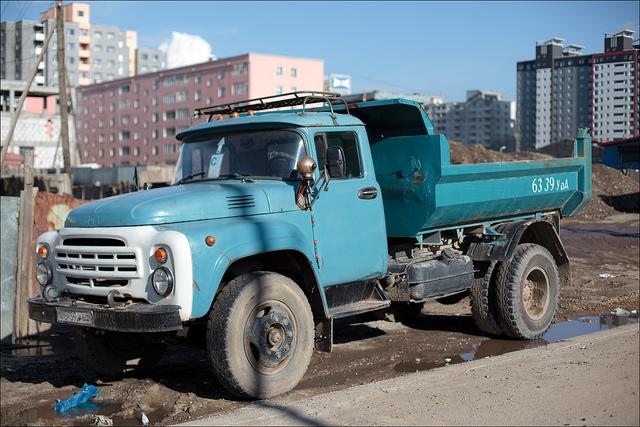What colors is the truck?
Concise answer only. Blue. What color is the cover of the lorry?
Write a very short answer. Blue. How many trucks?
Answer briefly. 1. What color are the stripes on this truck?
Answer briefly. Blue. What color is the truck?
Write a very short answer. Blue. Is this a rural area?
Quick response, please. No. What color is the jeep?
Answer briefly. Blue. What color are the wheels?
Write a very short answer. Black. Is this a dump truck?
Keep it brief. Yes. What kind of vehicle is this?
Concise answer only. Truck. Does the truck have it's headlights on?
Quick response, please. No. What is the truck parked next to?
Keep it brief. Street. How many wheels are on the truck?
Concise answer only. 6. What color is the bed of the truck?
Be succinct. Blue. How many wheels does the truck have?
Keep it brief. 6. 